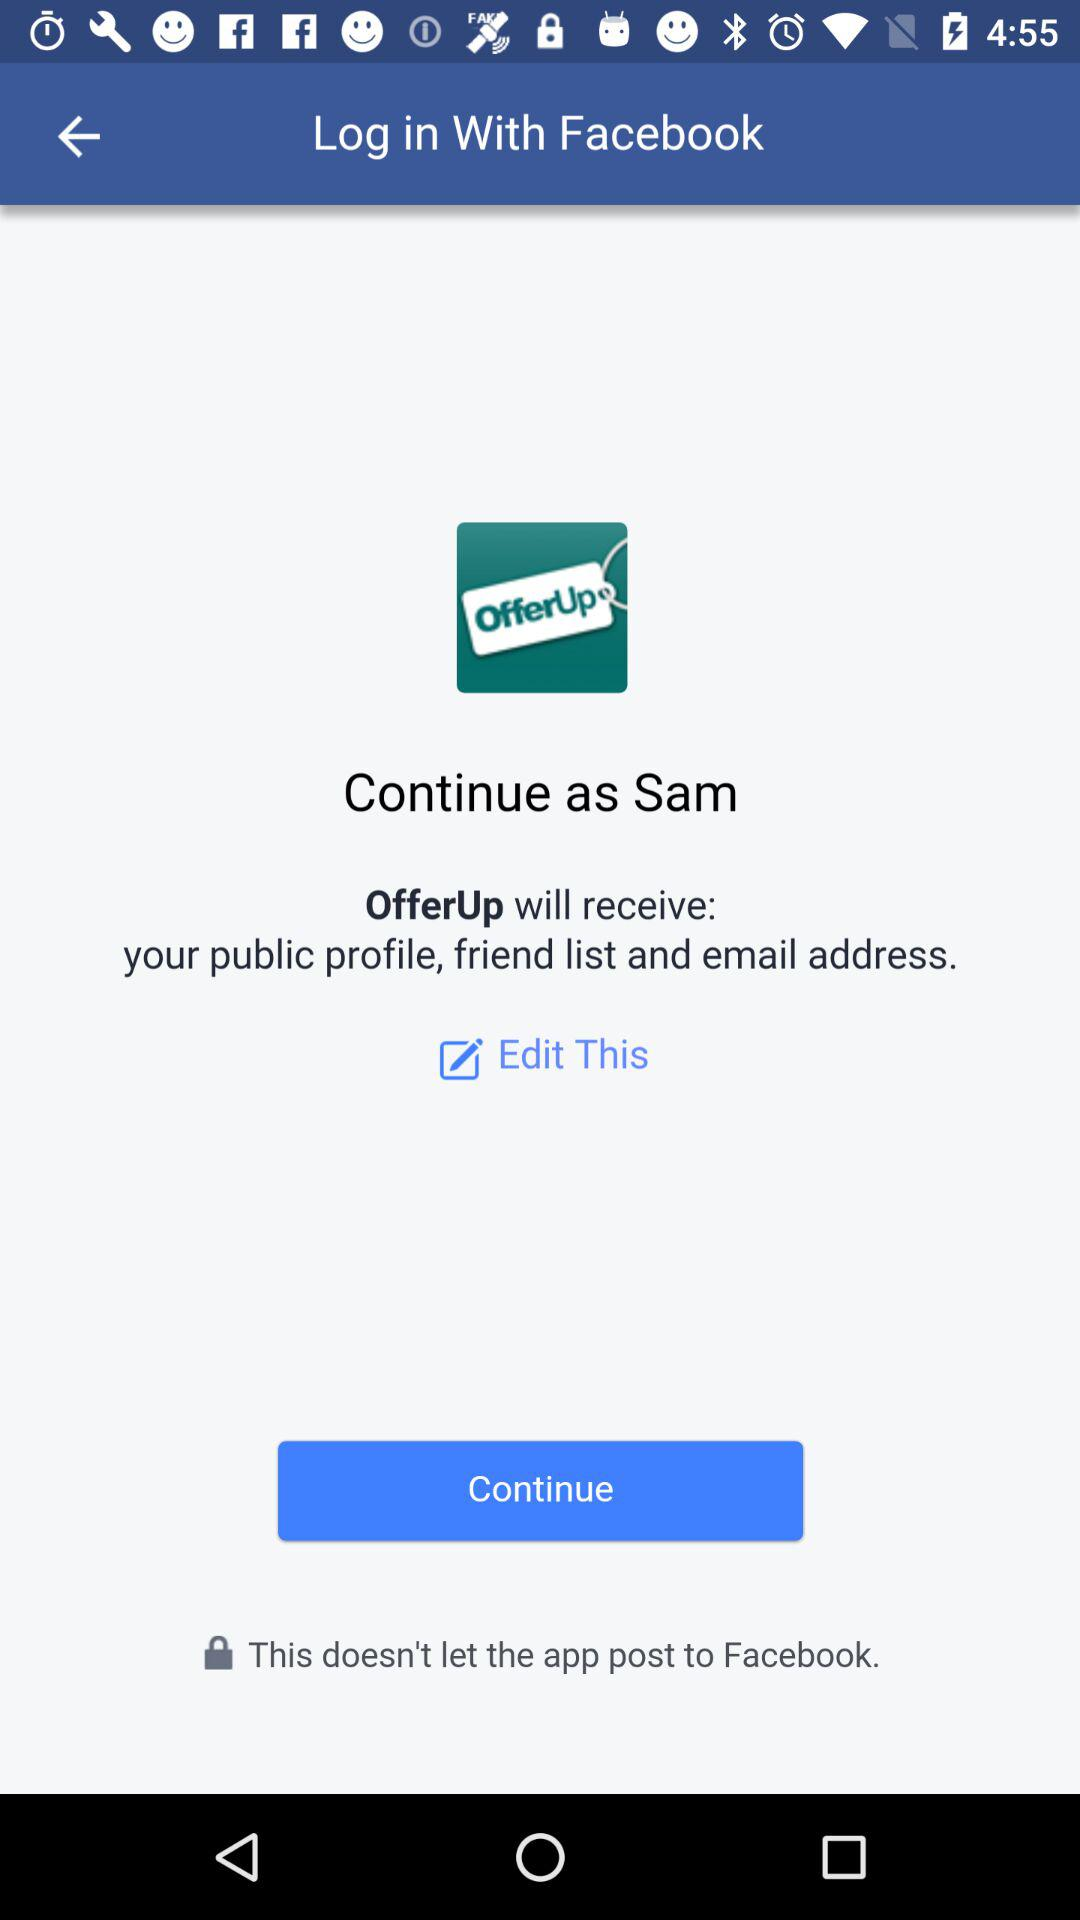What application will receive the public profile, friend list and email address? The application that will receive the public profile, friend list and email address is "OfferUp". 